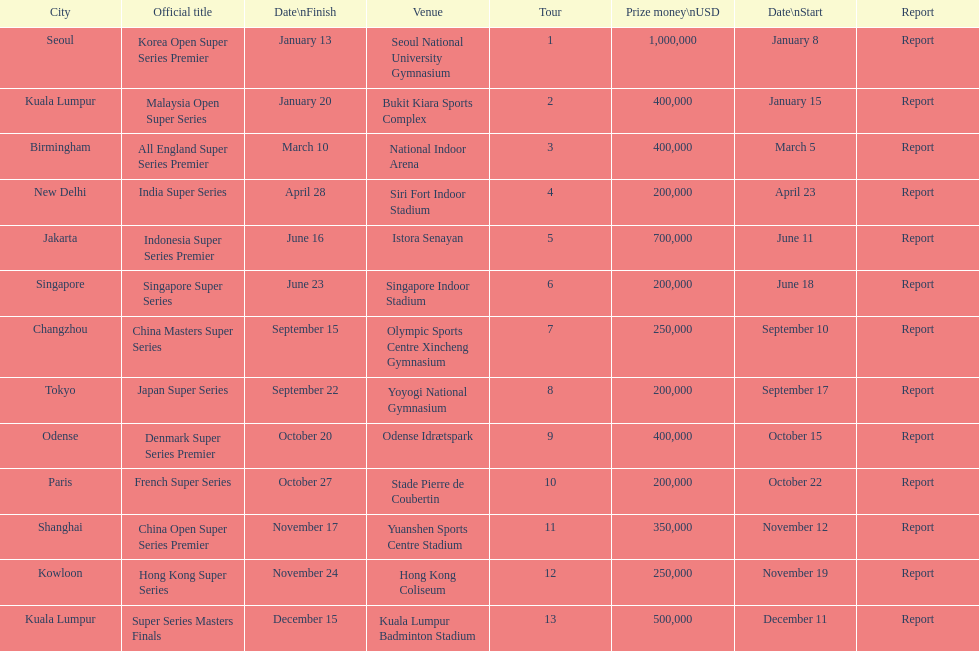Which tour was the only one to take place in december? Super Series Masters Finals. 